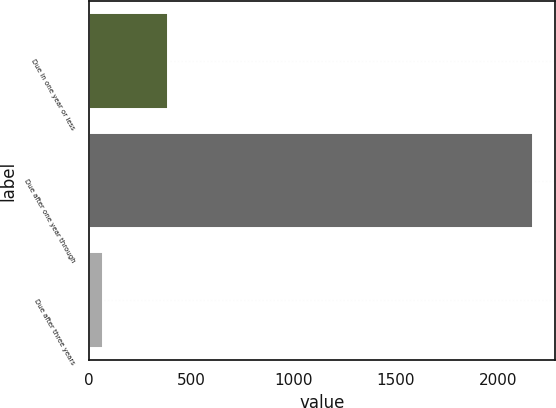Convert chart. <chart><loc_0><loc_0><loc_500><loc_500><bar_chart><fcel>Due in one year or less<fcel>Due after one year through<fcel>Due after three years<nl><fcel>383.7<fcel>2170.8<fcel>68.7<nl></chart> 